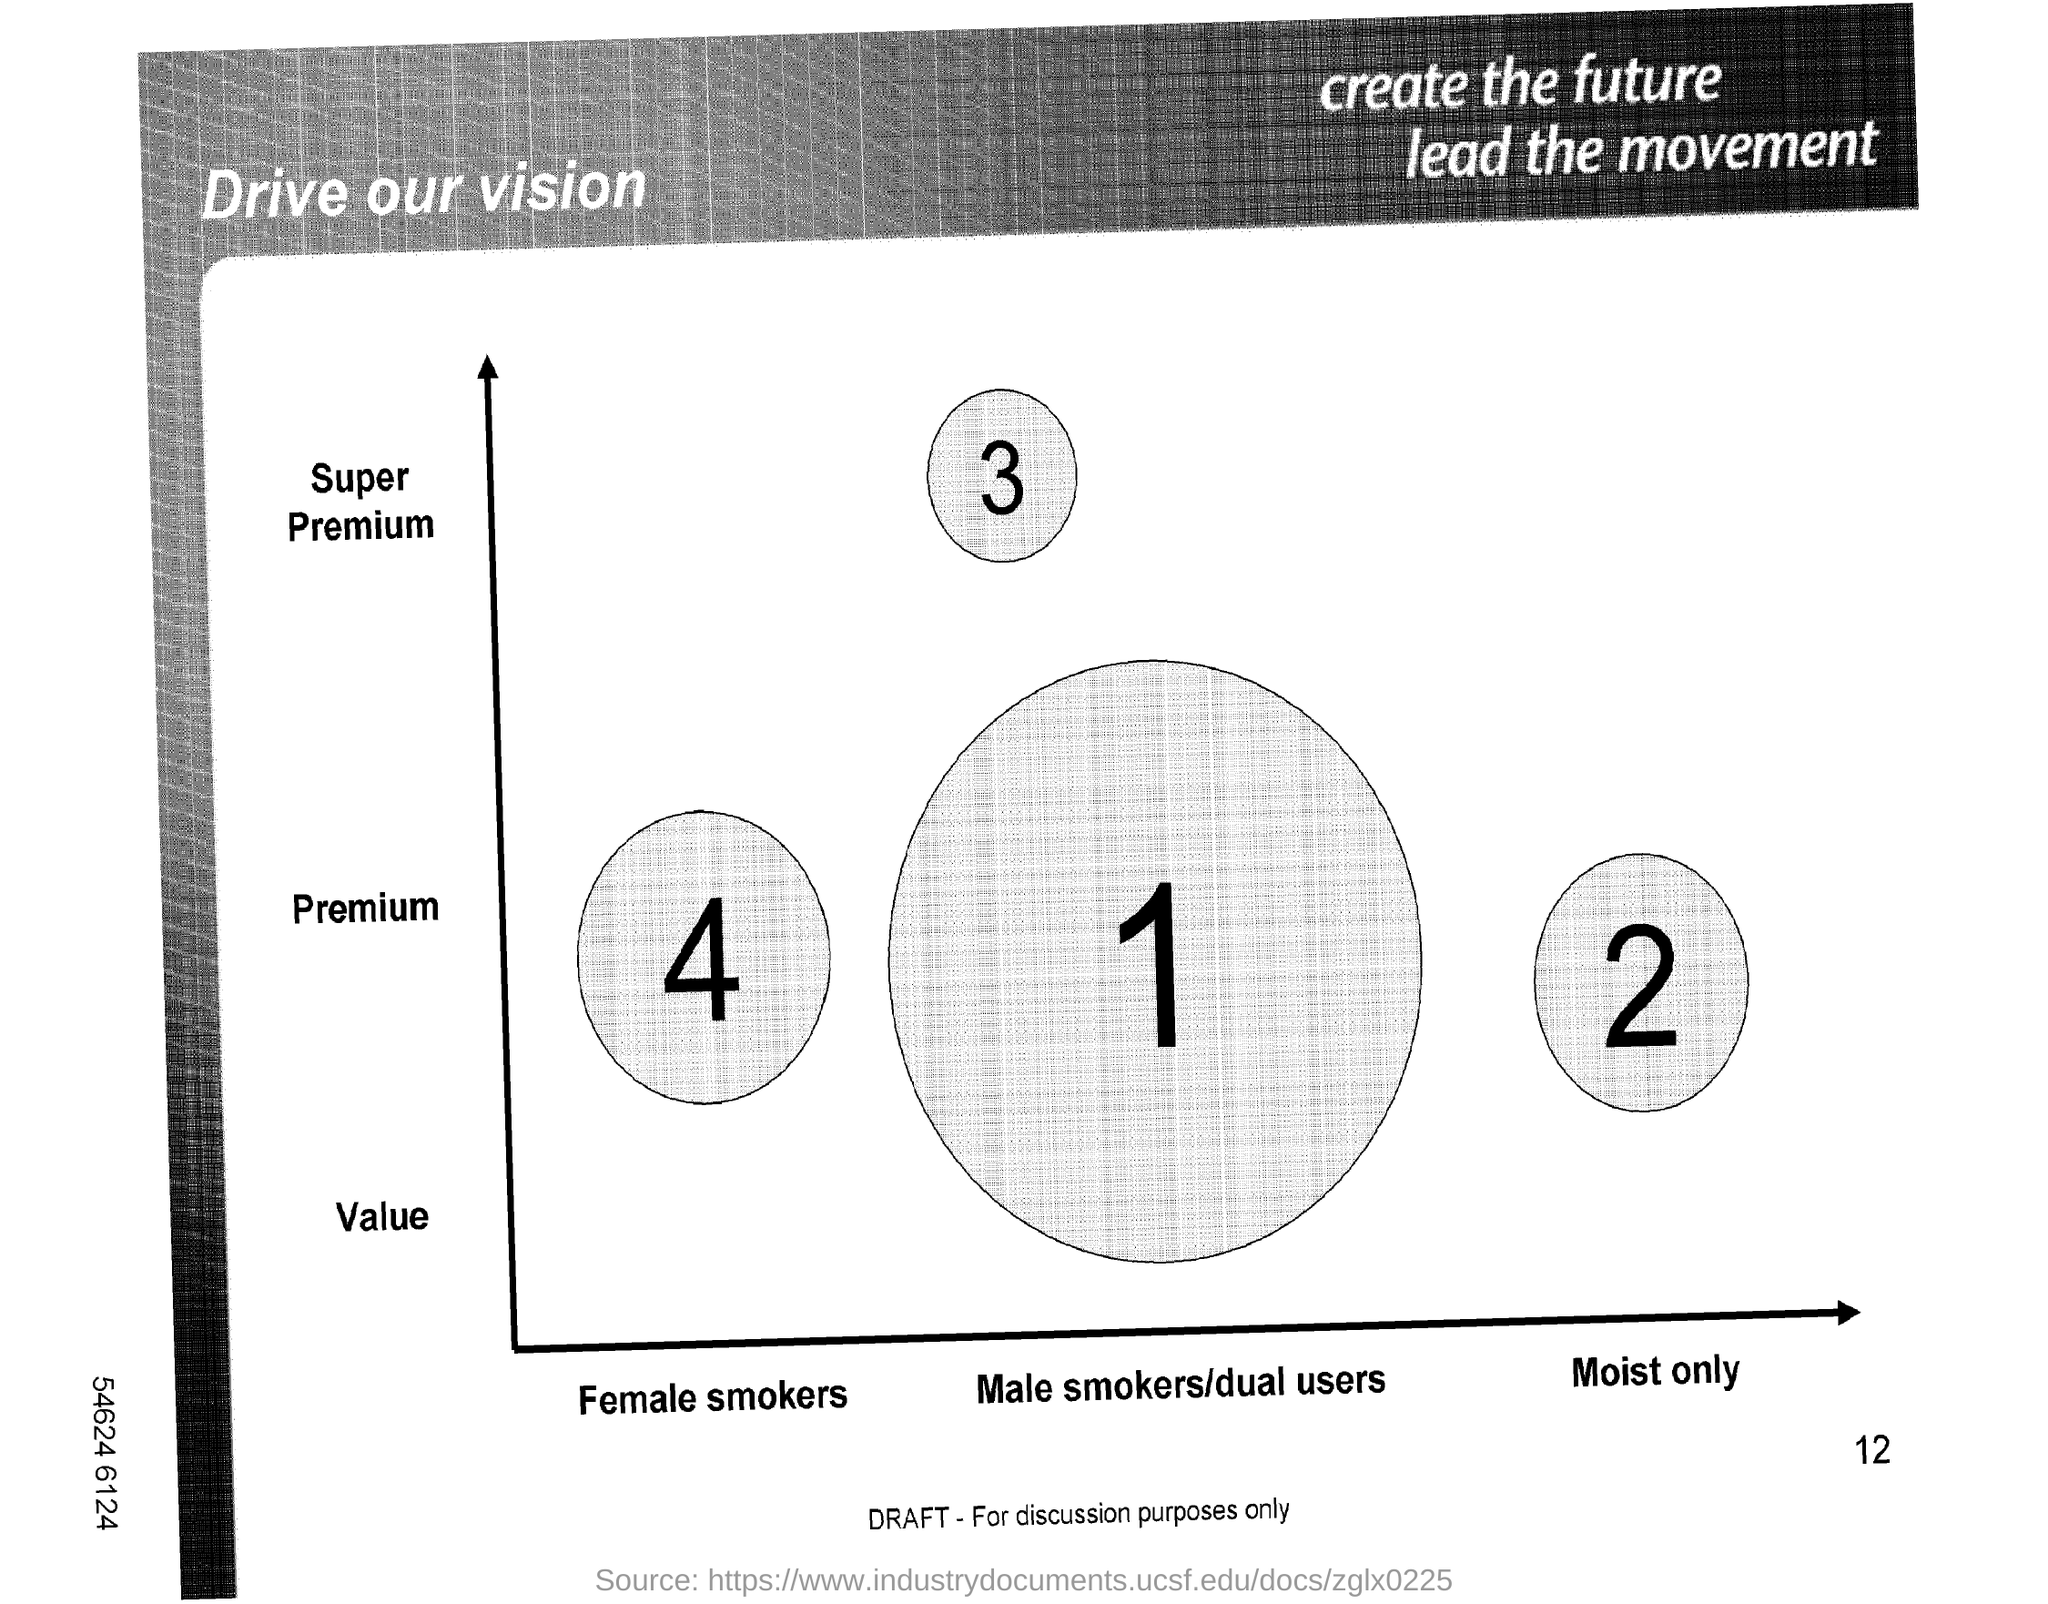Highlight a few significant elements in this photo. The title in the top right corner is the key to shaping the future of the movement. The title in the top left corner is 'Drive Our Vision,' which clearly communicates the primary objective of the document or concept being presented. 